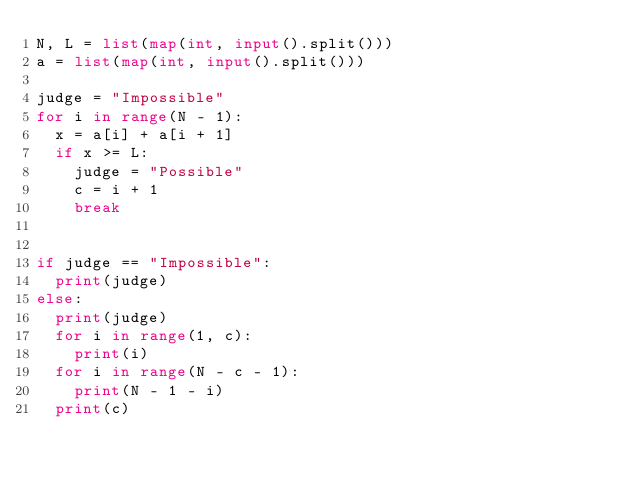<code> <loc_0><loc_0><loc_500><loc_500><_Python_>N, L = list(map(int, input().split()))
a = list(map(int, input().split()))

judge = "Impossible"
for i in range(N - 1):
	x = a[i] + a[i + 1]
	if x >= L:
		judge = "Possible"
		c = i + 1
		break


if judge == "Impossible":
	print(judge)
else:
	print(judge)
	for i in range(1, c):
		print(i)
	for i in range(N - c - 1):
		print(N - 1 - i)
	print(c)
</code> 